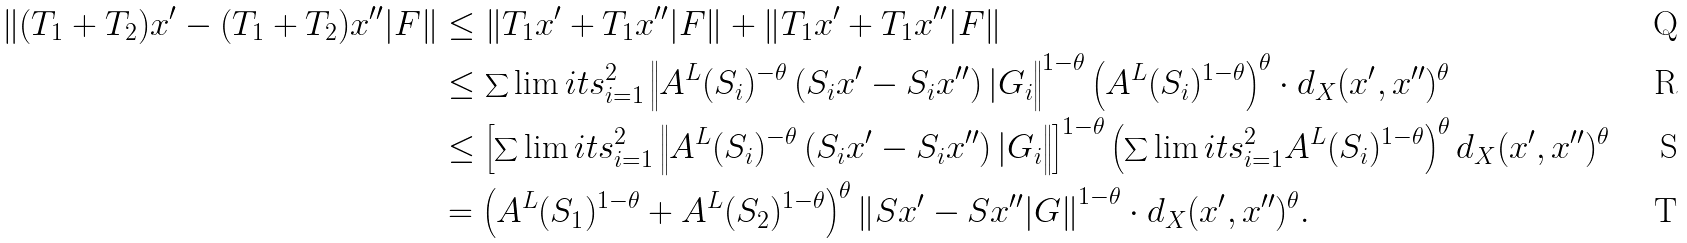Convert formula to latex. <formula><loc_0><loc_0><loc_500><loc_500>\left \| ( T _ { 1 } + T _ { 2 } ) x ^ { \prime } - ( T _ { 1 } + T _ { 2 } ) x ^ { \prime \prime } | F \right \| & \leq \left \| T _ { 1 } x ^ { \prime } + T _ { 1 } x ^ { \prime \prime } | F \right \| + \left \| T _ { 1 } x ^ { \prime } + T _ { 1 } x ^ { \prime \prime } | F \right \| \\ & \leq \sum \lim i t s _ { i = 1 } ^ { 2 } \left \| A ^ { L } ( S _ { i } ) ^ { - \theta } \left ( S _ { i } x ^ { \prime } - S _ { i } x ^ { \prime \prime } \right ) | G _ { i } \right \| ^ { 1 - \theta } \left ( A ^ { L } ( S _ { i } ) ^ { 1 - \theta } \right ) ^ { \theta } \cdot d _ { X } ( x ^ { \prime } , x ^ { \prime \prime } ) ^ { \theta } \\ & \leq \left [ \sum \lim i t s _ { i = 1 } ^ { 2 } \left \| A ^ { L } ( S _ { i } ) ^ { - \theta } \left ( S _ { i } x ^ { \prime } - S _ { i } x ^ { \prime \prime } \right ) | G _ { i } \right \| \right ] ^ { 1 - \theta } \left ( \sum \lim i t s _ { i = 1 } ^ { 2 } A ^ { L } ( S _ { i } ) ^ { 1 - \theta } \right ) ^ { \theta } d _ { X } ( x ^ { \prime } , x ^ { \prime \prime } ) ^ { \theta } \\ & = \left ( A ^ { L } ( S _ { 1 } ) ^ { 1 - \theta } + A ^ { L } ( S _ { 2 } ) ^ { 1 - \theta } \right ) ^ { \theta } \left \| S x ^ { \prime } - S x ^ { \prime \prime } | G \right \| ^ { 1 - \theta } \cdot d _ { X } ( x ^ { \prime } , x ^ { \prime \prime } ) ^ { \theta } .</formula> 